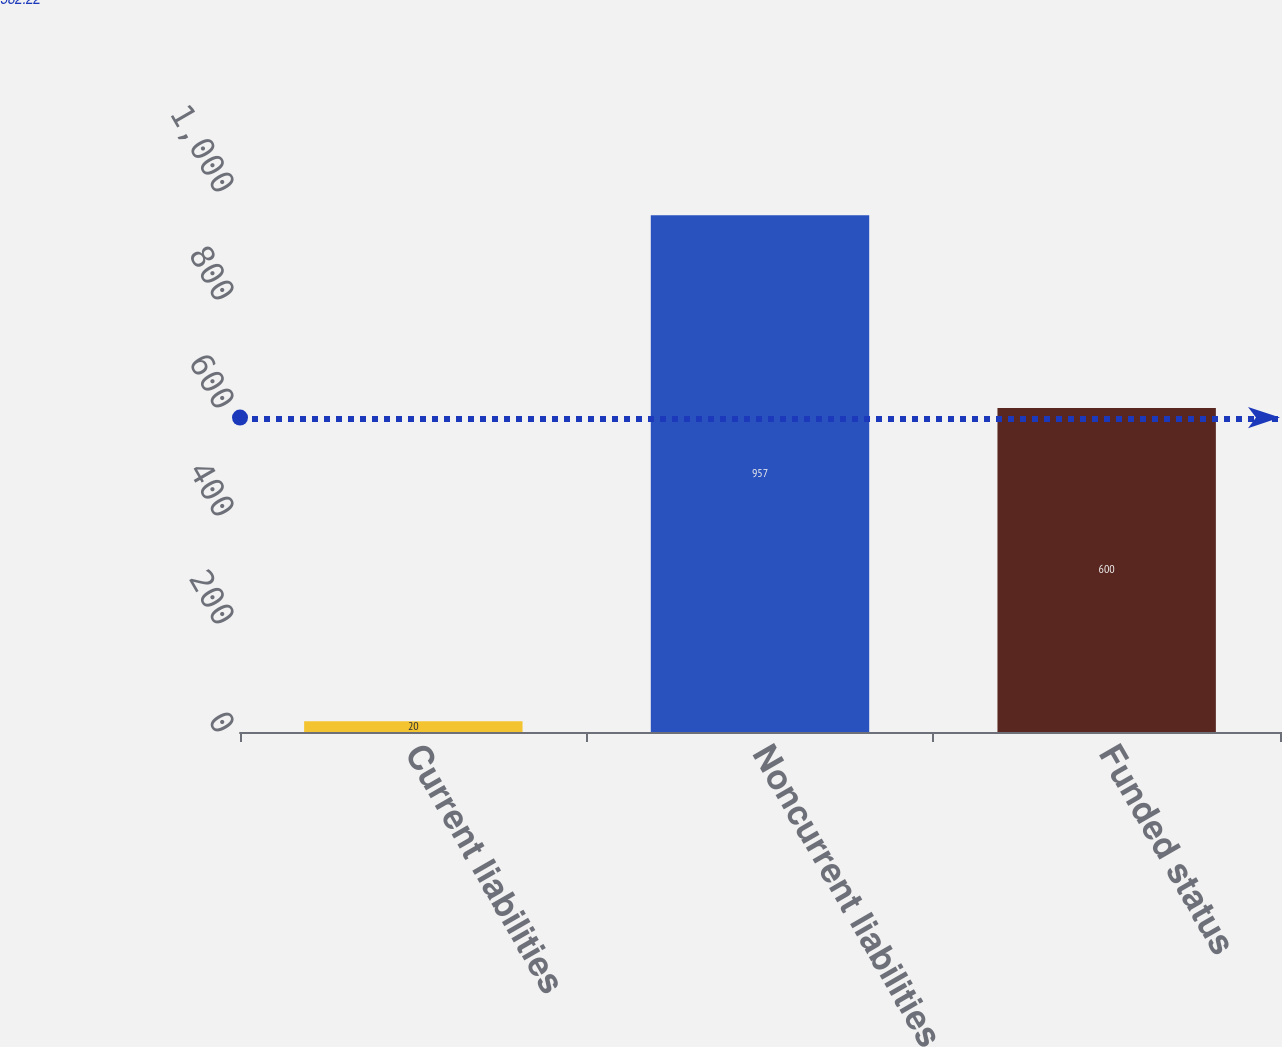Convert chart to OTSL. <chart><loc_0><loc_0><loc_500><loc_500><bar_chart><fcel>Current liabilities<fcel>Noncurrent liabilities<fcel>Funded status<nl><fcel>20<fcel>957<fcel>600<nl></chart> 